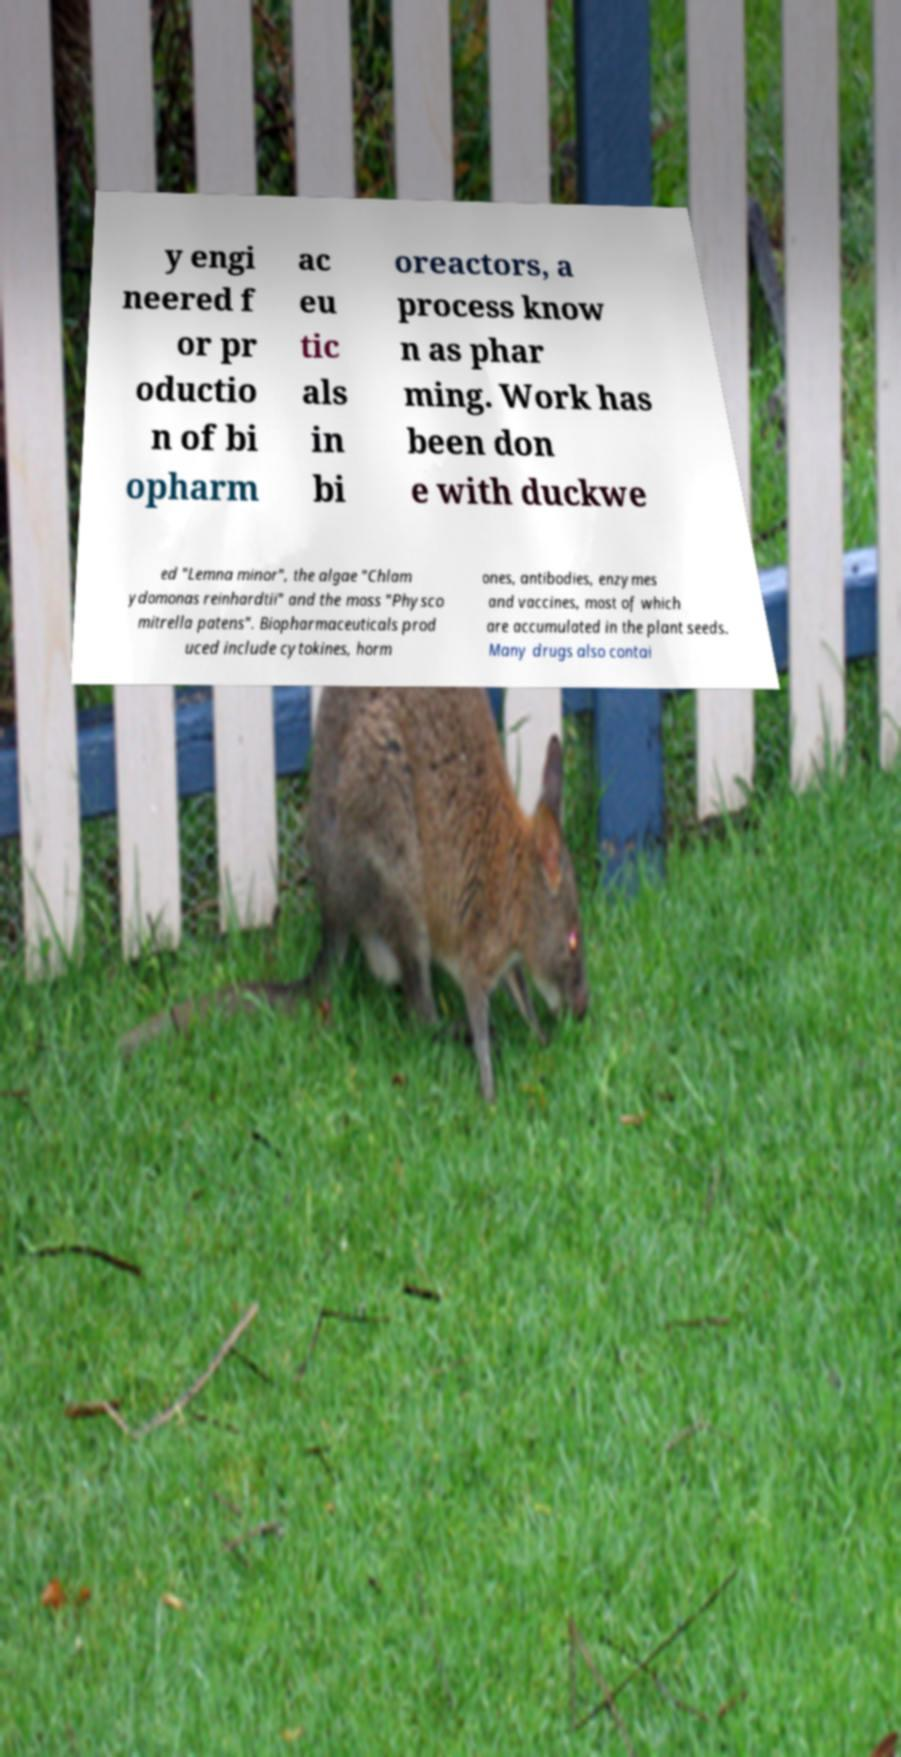Could you assist in decoding the text presented in this image and type it out clearly? y engi neered f or pr oductio n of bi opharm ac eu tic als in bi oreactors, a process know n as phar ming. Work has been don e with duckwe ed "Lemna minor", the algae "Chlam ydomonas reinhardtii" and the moss "Physco mitrella patens". Biopharmaceuticals prod uced include cytokines, horm ones, antibodies, enzymes and vaccines, most of which are accumulated in the plant seeds. Many drugs also contai 